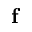<formula> <loc_0><loc_0><loc_500><loc_500>f</formula> 